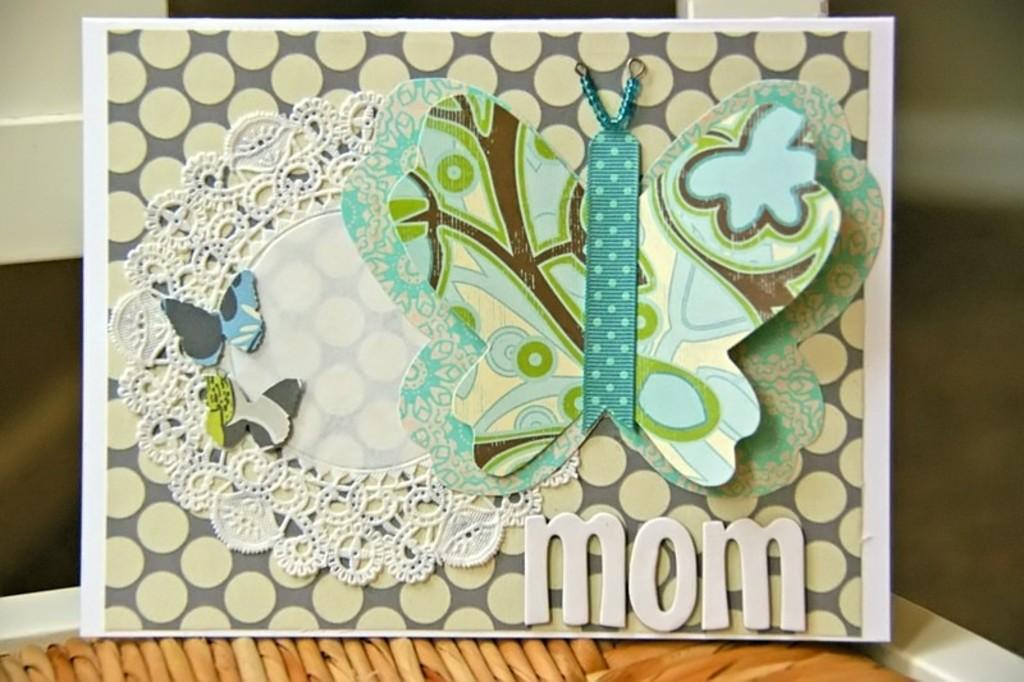What is the main object in the image? There is a board in the image. What decorations are on the board? There are stickers of butterflies on the board. Can you describe the background of the image? The background of the image is blurred. What type of division is being performed by the butterflies in the image? There is no division being performed by the butterflies in the image, as butterflies are not capable of performing mathematical operations. 